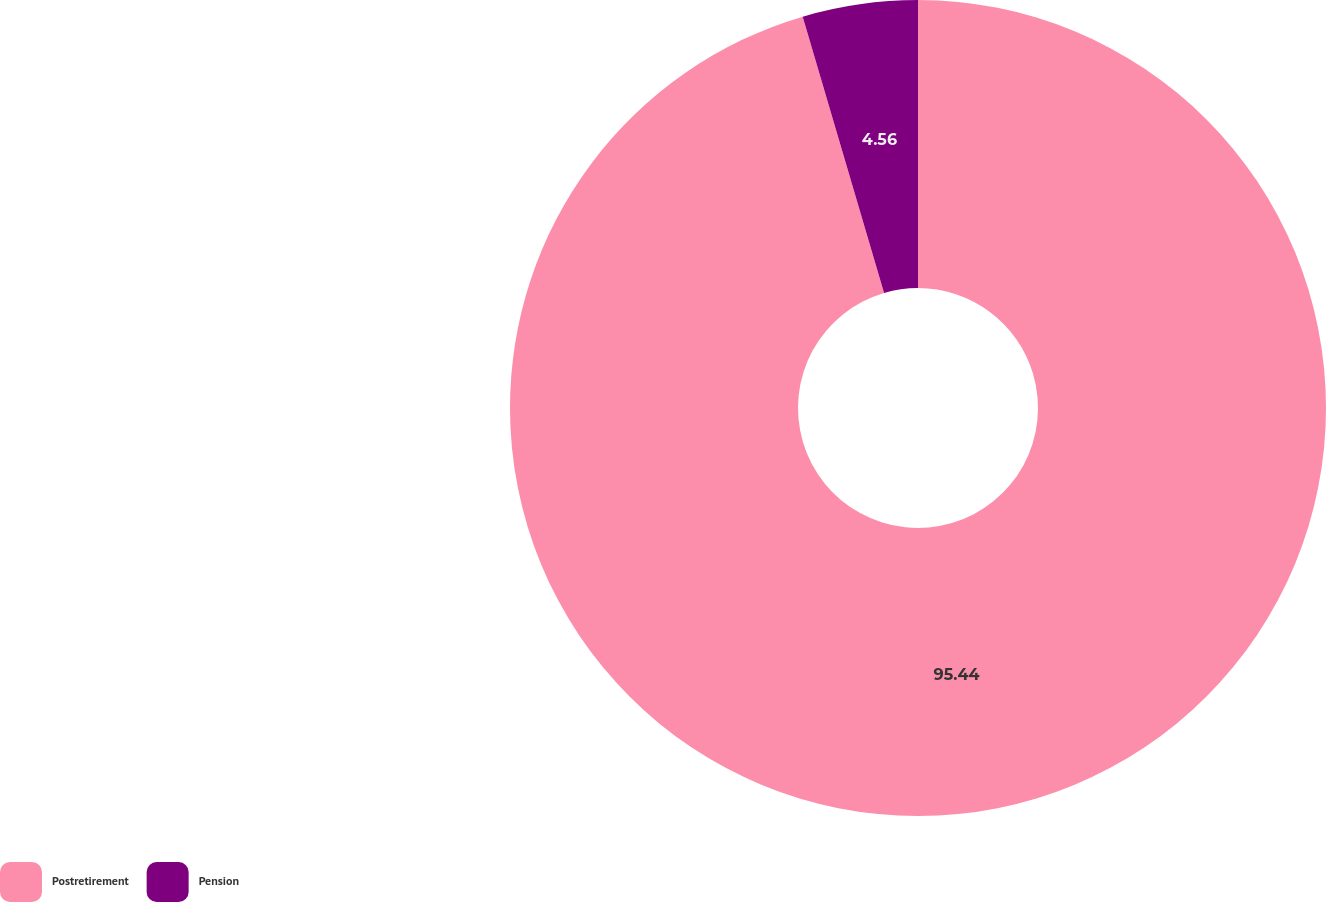Convert chart. <chart><loc_0><loc_0><loc_500><loc_500><pie_chart><fcel>Postretirement<fcel>Pension<nl><fcel>95.44%<fcel>4.56%<nl></chart> 